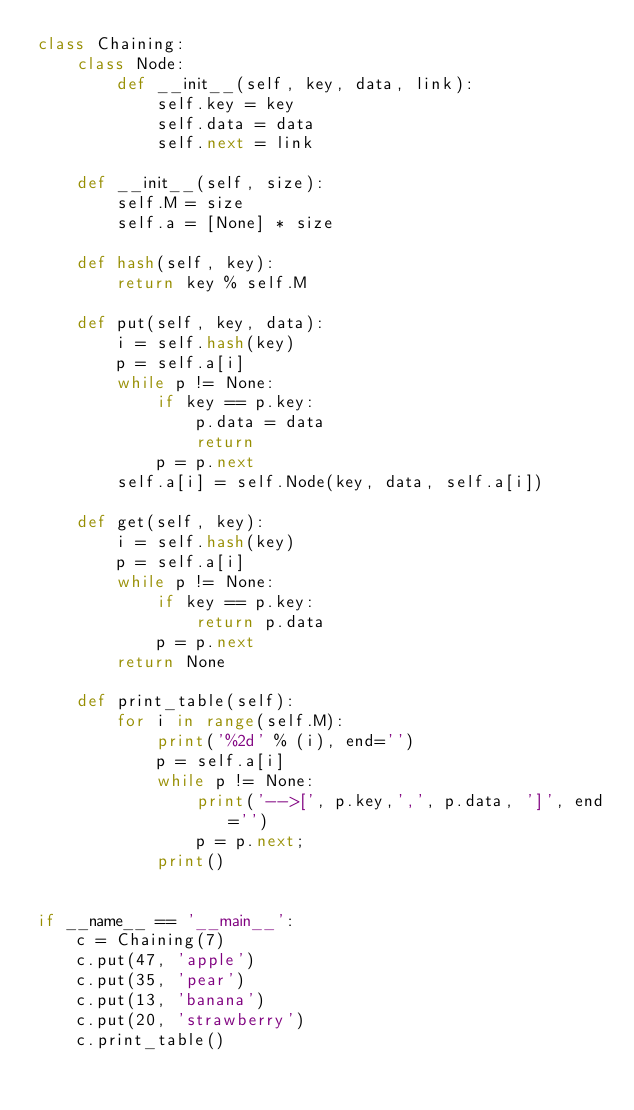<code> <loc_0><loc_0><loc_500><loc_500><_Python_>class Chaining:
    class Node:
        def __init__(self, key, data, link):
            self.key = key
            self.data = data
            self.next = link

    def __init__(self, size):
        self.M = size
        self.a = [None] * size

    def hash(self, key):
        return key % self.M

    def put(self, key, data):
        i = self.hash(key)
        p = self.a[i]
        while p != None:
            if key == p.key:
                p.data = data
                return
            p = p.next
        self.a[i] = self.Node(key, data, self.a[i])

    def get(self, key):
        i = self.hash(key)
        p = self.a[i]
        while p != None:
            if key == p.key:
                return p.data
            p = p.next
        return None

    def print_table(self):
        for i in range(self.M):
            print('%2d' % (i), end='')
            p = self.a[i]
            while p != None:
                print('-->[', p.key,',', p.data, ']', end='')
                p = p.next;
            print()


if __name__ == '__main__':
    c = Chaining(7)
    c.put(47, 'apple')
    c.put(35, 'pear')
    c.put(13, 'banana')
    c.put(20, 'strawberry')
    c.print_table()
</code> 